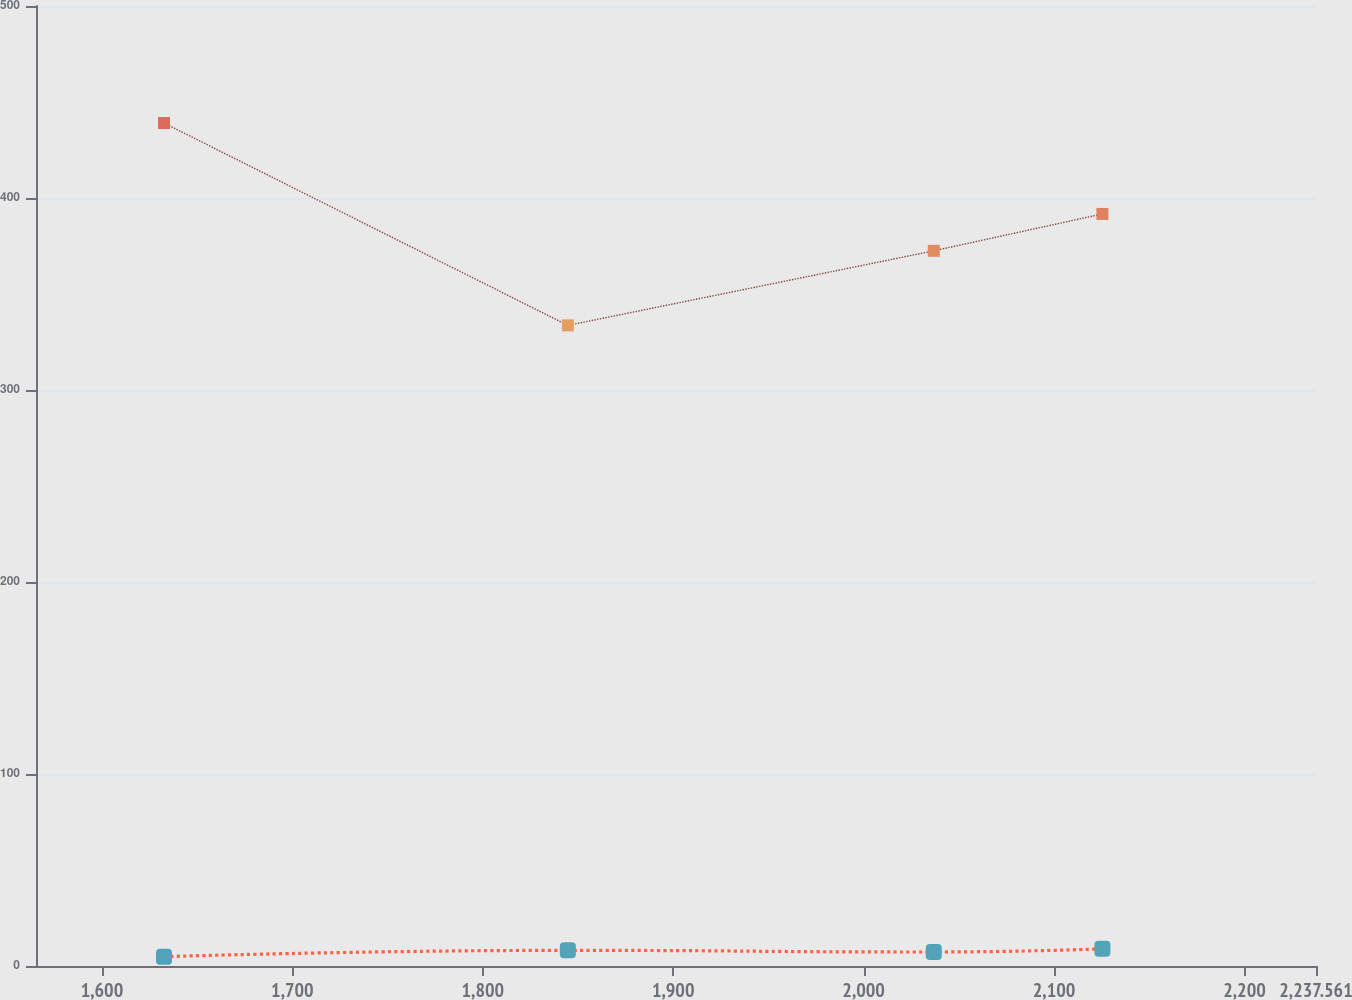Convert chart. <chart><loc_0><loc_0><loc_500><loc_500><line_chart><ecel><fcel>Post-Retirement Benefit Plans<fcel>Defined Benefit Plans<nl><fcel>1632.59<fcel>439.04<fcel>4.86<nl><fcel>1844.67<fcel>333.65<fcel>8.15<nl><fcel>2036.85<fcel>372.49<fcel>7.29<nl><fcel>2125.4<fcel>391.7<fcel>8.95<nl><fcel>2304.78<fcel>496.03<fcel>9.38<nl></chart> 